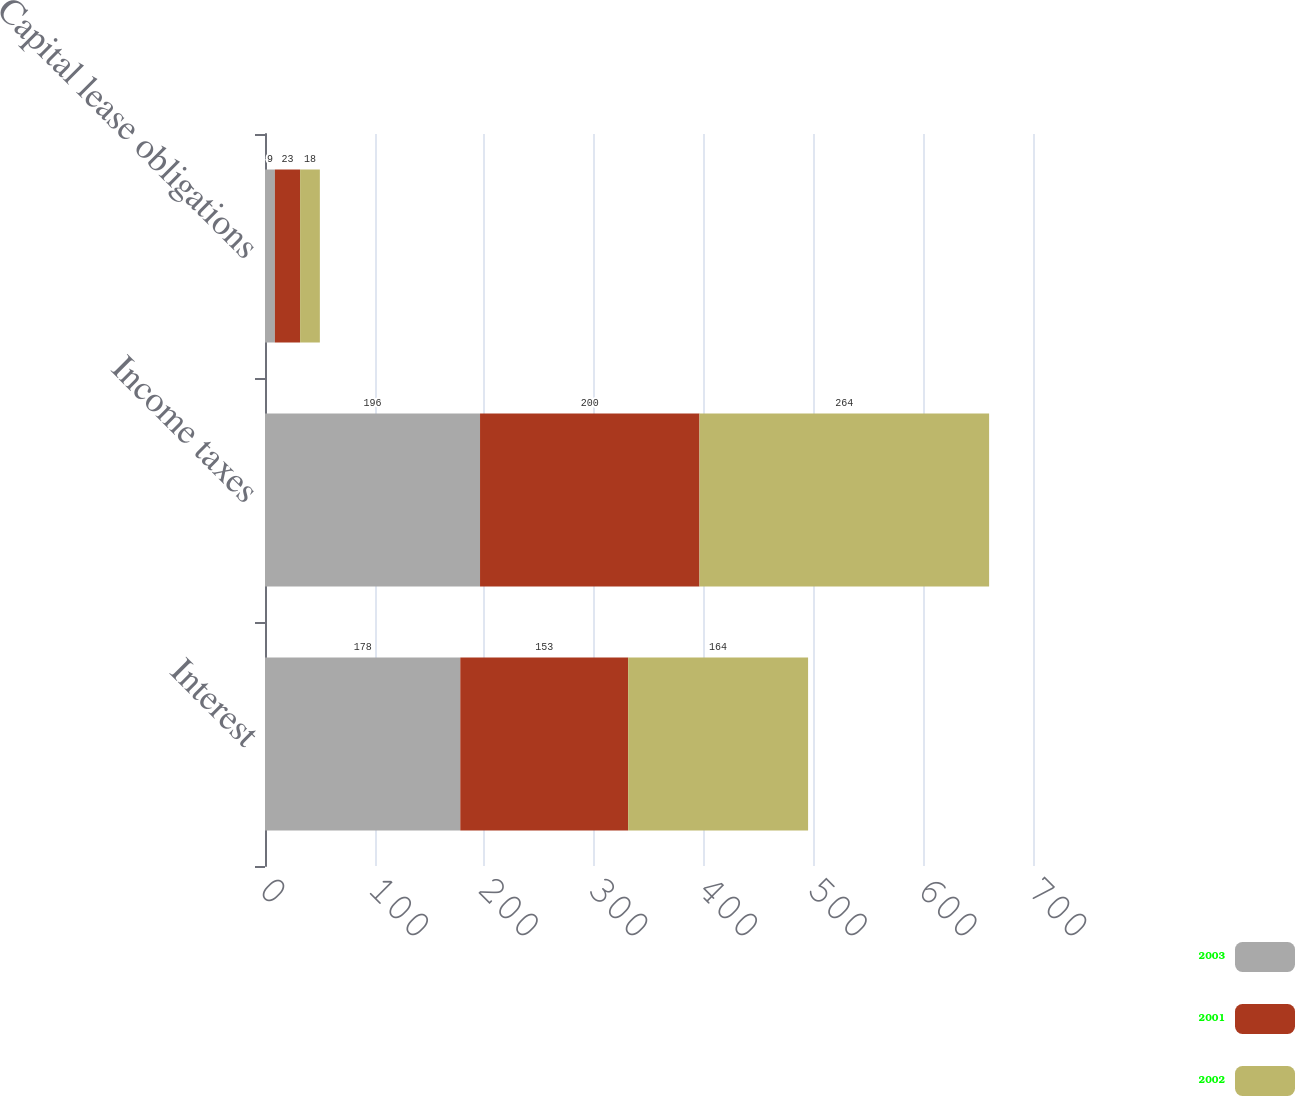<chart> <loc_0><loc_0><loc_500><loc_500><stacked_bar_chart><ecel><fcel>Interest<fcel>Income taxes<fcel>Capital lease obligations<nl><fcel>2003<fcel>178<fcel>196<fcel>9<nl><fcel>2001<fcel>153<fcel>200<fcel>23<nl><fcel>2002<fcel>164<fcel>264<fcel>18<nl></chart> 